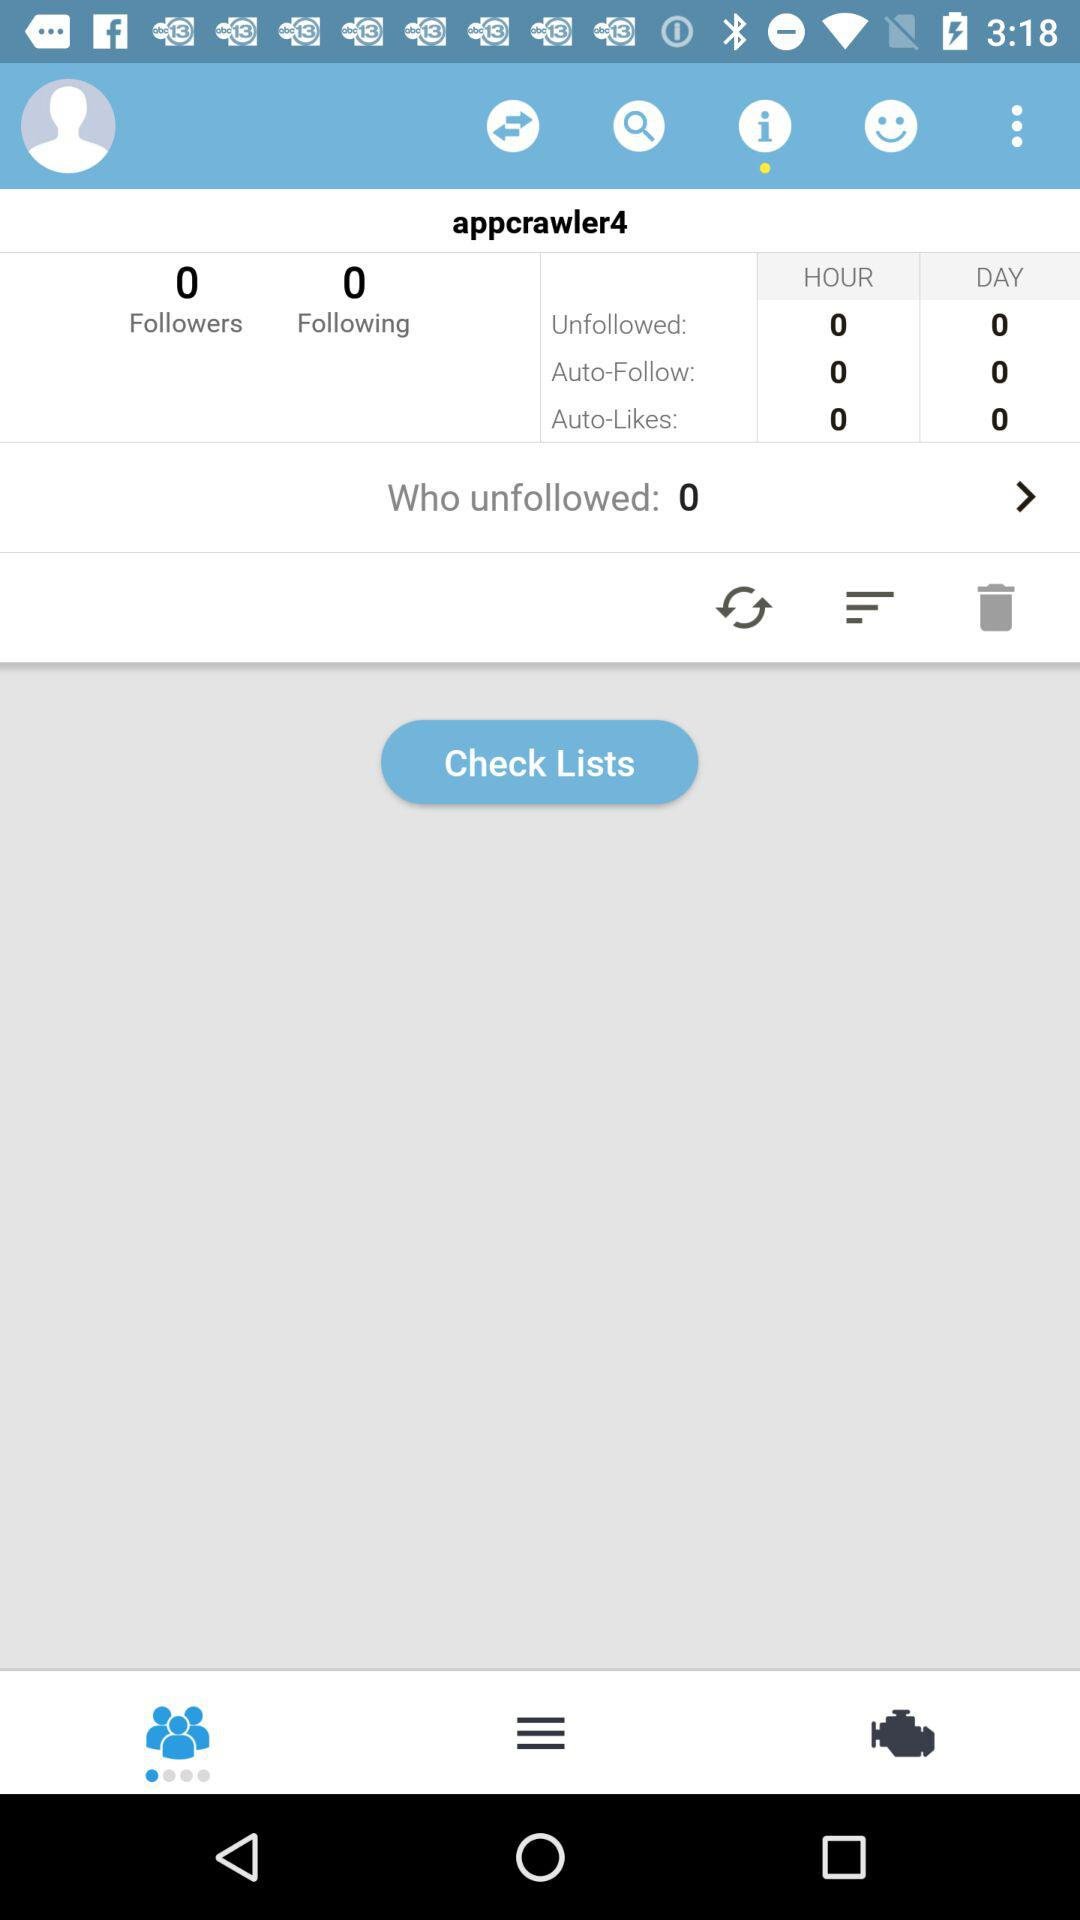How many people have unfollowed you? There are 0 people who have unfollowed you. 